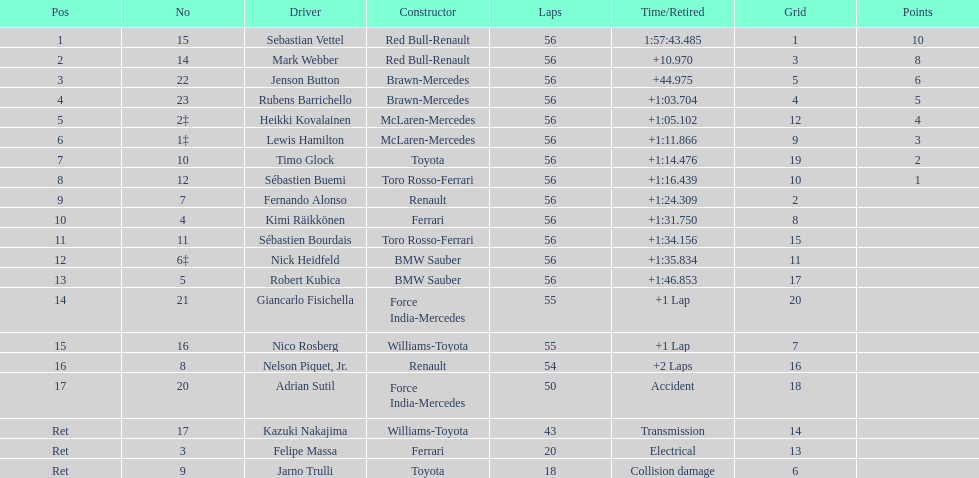How many drivers did not finish 56 laps? 7. 